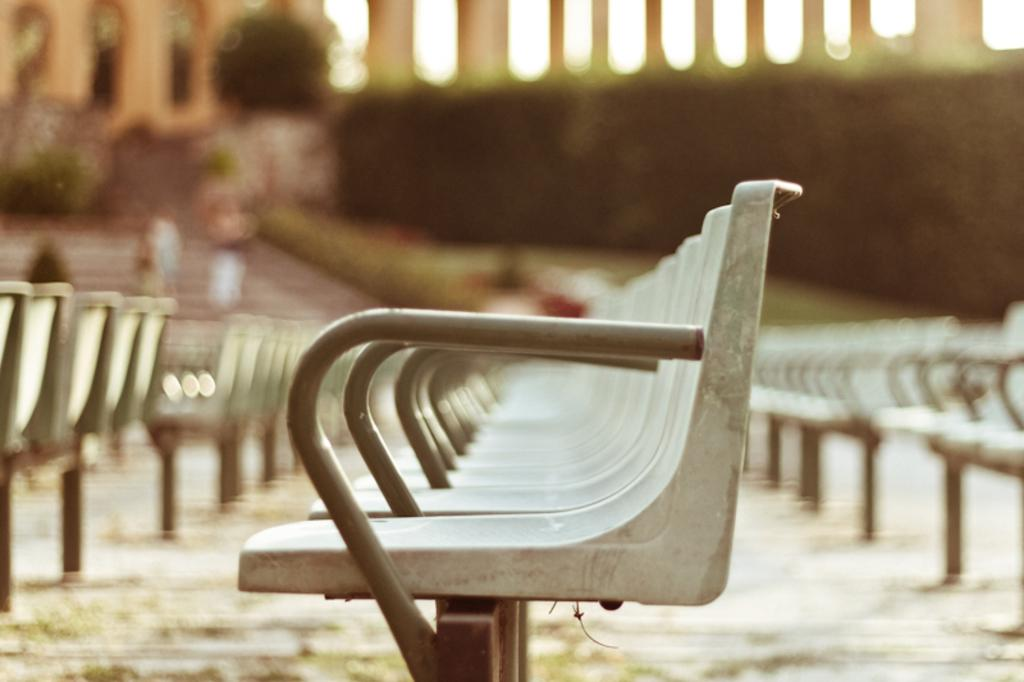What type of furniture is located in the center of the image? There are attached chairs in the center of the image. What can be seen in the background of the image? There is a building, pillars, plants, and two persons standing on a staircase in the background of the image. Are there any other objects visible in the background of the image? Yes, there are a few other objects in the background of the image. What time of day is it in the image, and can you see the brain of one of the persons standing on the staircase? The time of day cannot be determined from the image, and there is no indication of anyone's brain being visible. 